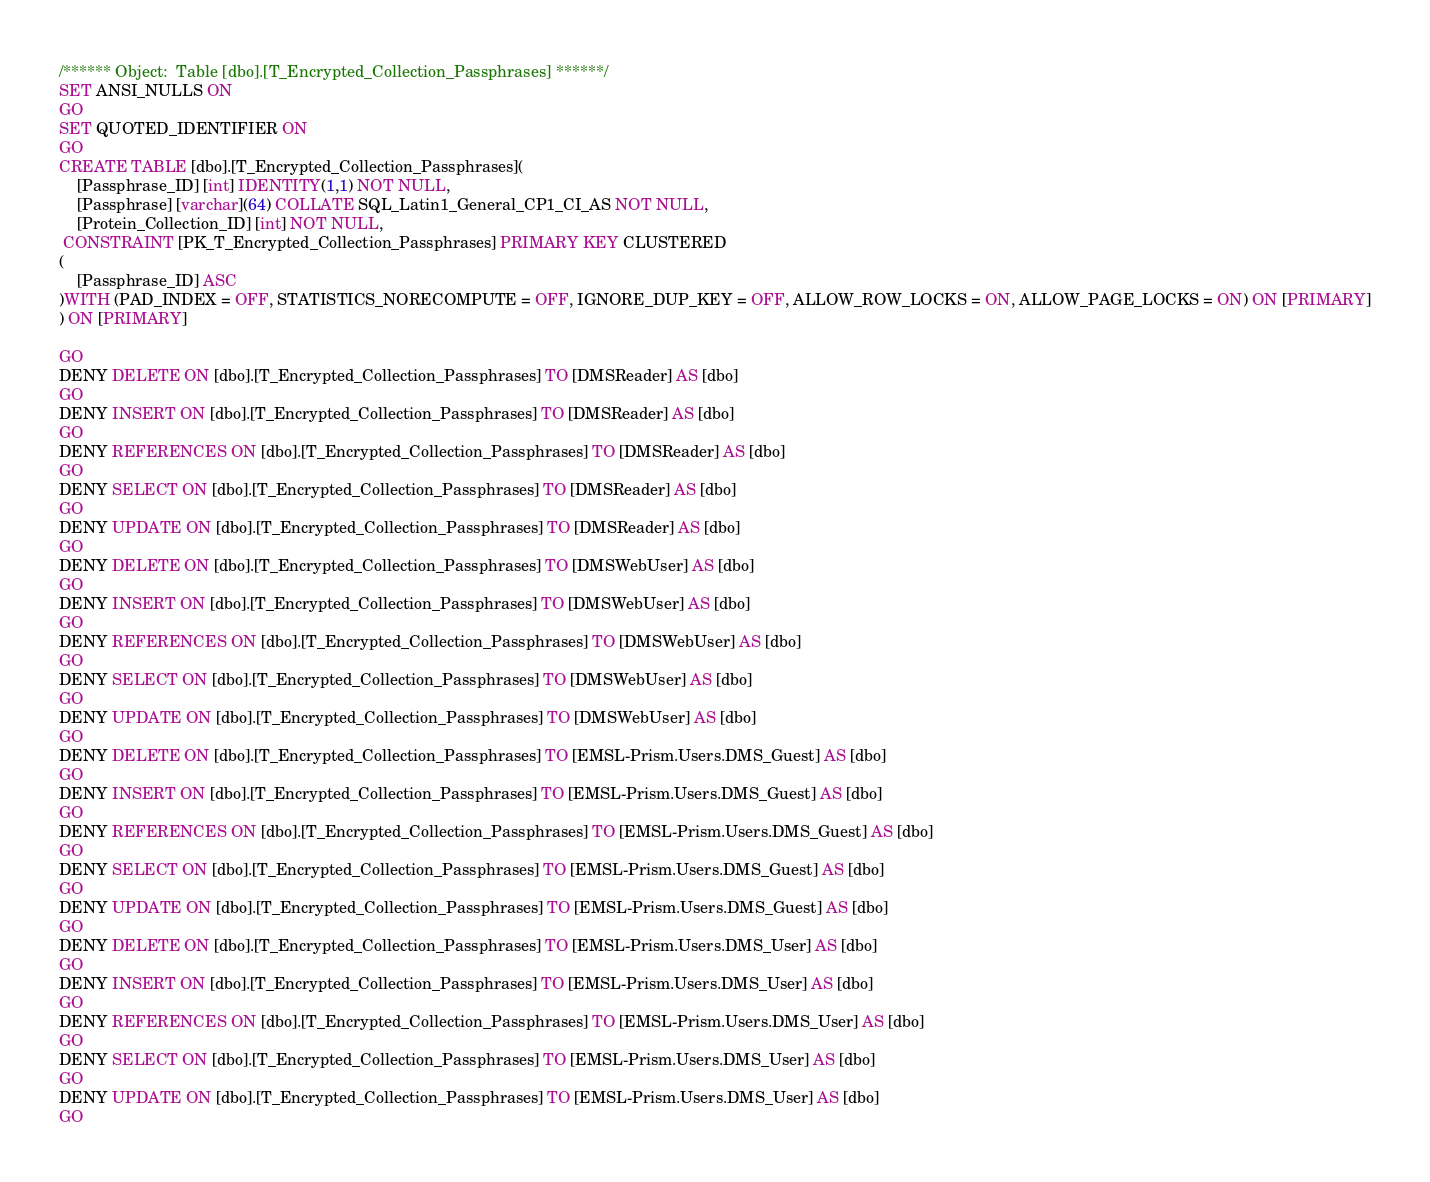<code> <loc_0><loc_0><loc_500><loc_500><_SQL_>/****** Object:  Table [dbo].[T_Encrypted_Collection_Passphrases] ******/
SET ANSI_NULLS ON
GO
SET QUOTED_IDENTIFIER ON
GO
CREATE TABLE [dbo].[T_Encrypted_Collection_Passphrases](
	[Passphrase_ID] [int] IDENTITY(1,1) NOT NULL,
	[Passphrase] [varchar](64) COLLATE SQL_Latin1_General_CP1_CI_AS NOT NULL,
	[Protein_Collection_ID] [int] NOT NULL,
 CONSTRAINT [PK_T_Encrypted_Collection_Passphrases] PRIMARY KEY CLUSTERED 
(
	[Passphrase_ID] ASC
)WITH (PAD_INDEX = OFF, STATISTICS_NORECOMPUTE = OFF, IGNORE_DUP_KEY = OFF, ALLOW_ROW_LOCKS = ON, ALLOW_PAGE_LOCKS = ON) ON [PRIMARY]
) ON [PRIMARY]

GO
DENY DELETE ON [dbo].[T_Encrypted_Collection_Passphrases] TO [DMSReader] AS [dbo]
GO
DENY INSERT ON [dbo].[T_Encrypted_Collection_Passphrases] TO [DMSReader] AS [dbo]
GO
DENY REFERENCES ON [dbo].[T_Encrypted_Collection_Passphrases] TO [DMSReader] AS [dbo]
GO
DENY SELECT ON [dbo].[T_Encrypted_Collection_Passphrases] TO [DMSReader] AS [dbo]
GO
DENY UPDATE ON [dbo].[T_Encrypted_Collection_Passphrases] TO [DMSReader] AS [dbo]
GO
DENY DELETE ON [dbo].[T_Encrypted_Collection_Passphrases] TO [DMSWebUser] AS [dbo]
GO
DENY INSERT ON [dbo].[T_Encrypted_Collection_Passphrases] TO [DMSWebUser] AS [dbo]
GO
DENY REFERENCES ON [dbo].[T_Encrypted_Collection_Passphrases] TO [DMSWebUser] AS [dbo]
GO
DENY SELECT ON [dbo].[T_Encrypted_Collection_Passphrases] TO [DMSWebUser] AS [dbo]
GO
DENY UPDATE ON [dbo].[T_Encrypted_Collection_Passphrases] TO [DMSWebUser] AS [dbo]
GO
DENY DELETE ON [dbo].[T_Encrypted_Collection_Passphrases] TO [EMSL-Prism.Users.DMS_Guest] AS [dbo]
GO
DENY INSERT ON [dbo].[T_Encrypted_Collection_Passphrases] TO [EMSL-Prism.Users.DMS_Guest] AS [dbo]
GO
DENY REFERENCES ON [dbo].[T_Encrypted_Collection_Passphrases] TO [EMSL-Prism.Users.DMS_Guest] AS [dbo]
GO
DENY SELECT ON [dbo].[T_Encrypted_Collection_Passphrases] TO [EMSL-Prism.Users.DMS_Guest] AS [dbo]
GO
DENY UPDATE ON [dbo].[T_Encrypted_Collection_Passphrases] TO [EMSL-Prism.Users.DMS_Guest] AS [dbo]
GO
DENY DELETE ON [dbo].[T_Encrypted_Collection_Passphrases] TO [EMSL-Prism.Users.DMS_User] AS [dbo]
GO
DENY INSERT ON [dbo].[T_Encrypted_Collection_Passphrases] TO [EMSL-Prism.Users.DMS_User] AS [dbo]
GO
DENY REFERENCES ON [dbo].[T_Encrypted_Collection_Passphrases] TO [EMSL-Prism.Users.DMS_User] AS [dbo]
GO
DENY SELECT ON [dbo].[T_Encrypted_Collection_Passphrases] TO [EMSL-Prism.Users.DMS_User] AS [dbo]
GO
DENY UPDATE ON [dbo].[T_Encrypted_Collection_Passphrases] TO [EMSL-Prism.Users.DMS_User] AS [dbo]
GO</code> 